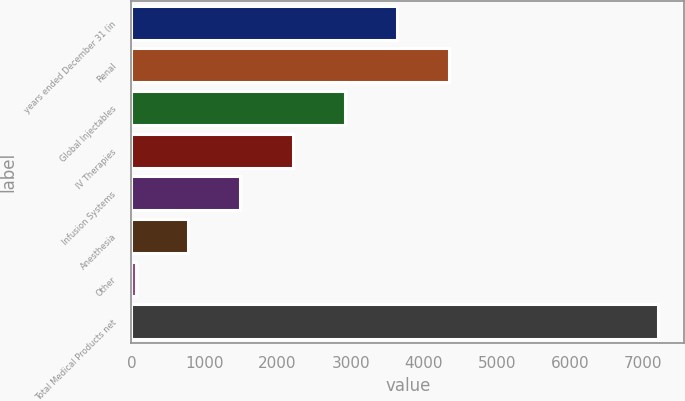<chart> <loc_0><loc_0><loc_500><loc_500><bar_chart><fcel>years ended December 31 (in<fcel>Renal<fcel>Global Injectables<fcel>IV Therapies<fcel>Infusion Systems<fcel>Anesthesia<fcel>Other<fcel>Total Medical Products net<nl><fcel>3634<fcel>4347.8<fcel>2920.2<fcel>2206.4<fcel>1492.6<fcel>778.8<fcel>65<fcel>7203<nl></chart> 